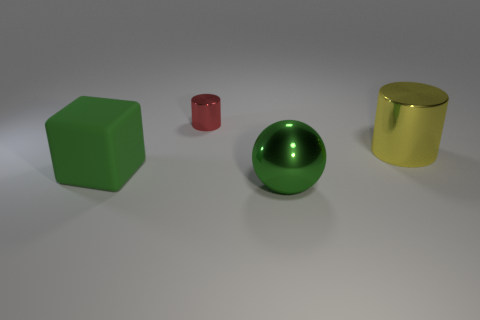Add 4 tiny red cylinders. How many objects exist? 8 Subtract all blocks. How many objects are left? 3 Add 2 balls. How many balls exist? 3 Subtract 0 gray cylinders. How many objects are left? 4 Subtract all blue matte balls. Subtract all tiny red cylinders. How many objects are left? 3 Add 4 yellow shiny objects. How many yellow shiny objects are left? 5 